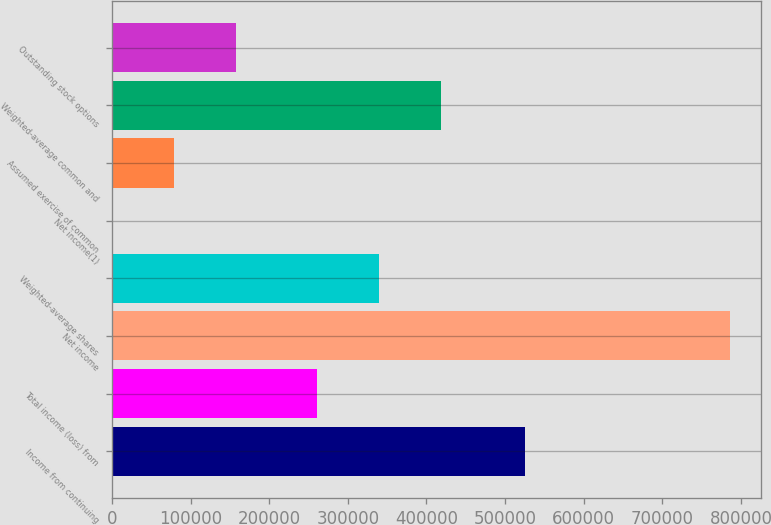<chart> <loc_0><loc_0><loc_500><loc_500><bar_chart><fcel>Income from continuing<fcel>Total income (loss) from<fcel>Net income<fcel>Weighted-average shares<fcel>Net income(1)<fcel>Assumed exercise of common<fcel>Weighted-average common and<fcel>Outstanding stock options<nl><fcel>525177<fcel>261107<fcel>786284<fcel>339735<fcel>2.69<fcel>78630.8<fcel>418363<fcel>157259<nl></chart> 